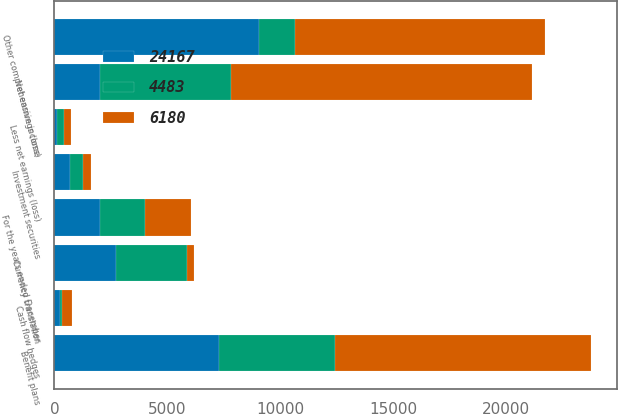Convert chart to OTSL. <chart><loc_0><loc_0><loc_500><loc_500><stacked_bar_chart><ecel><fcel>For the years ended December<fcel>Net earnings (loss)<fcel>Less net earnings (loss)<fcel>Investment securities<fcel>Currency translation<fcel>Cash flow hedges<fcel>Benefit plans<fcel>Other comprehensive income<nl><fcel>4483<fcel>2015<fcel>5795<fcel>332<fcel>553<fcel>3137<fcel>99<fcel>5165<fcel>1575<nl><fcel>24167<fcel>2014<fcel>2013<fcel>112<fcel>708<fcel>2730<fcel>234<fcel>7278<fcel>9066<nl><fcel>6180<fcel>2013<fcel>13355<fcel>298<fcel>374<fcel>308<fcel>466<fcel>11300<fcel>11084<nl></chart> 